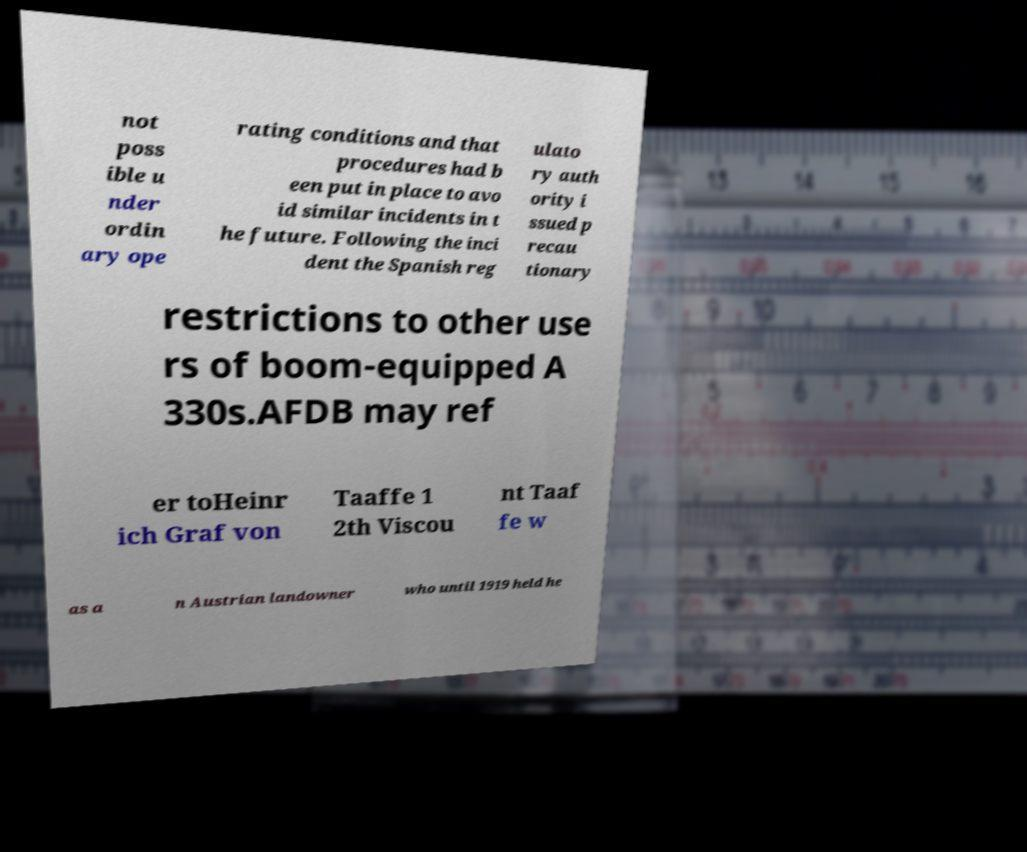Could you extract and type out the text from this image? not poss ible u nder ordin ary ope rating conditions and that procedures had b een put in place to avo id similar incidents in t he future. Following the inci dent the Spanish reg ulato ry auth ority i ssued p recau tionary restrictions to other use rs of boom-equipped A 330s.AFDB may ref er toHeinr ich Graf von Taaffe 1 2th Viscou nt Taaf fe w as a n Austrian landowner who until 1919 held he 